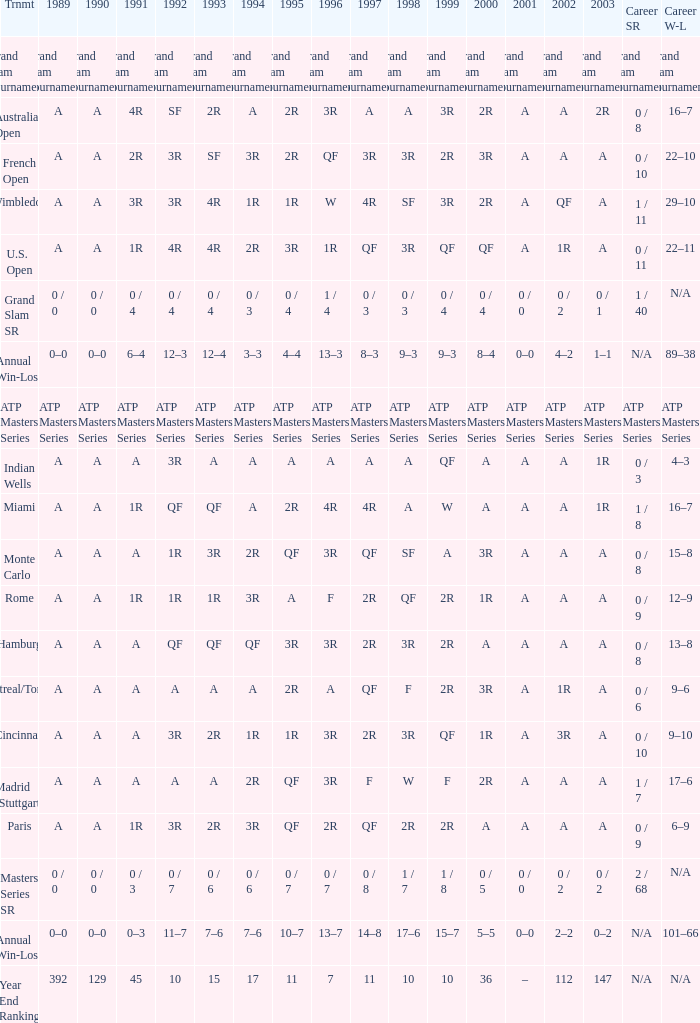Can you give me this table as a dict? {'header': ['Trnmt', '1989', '1990', '1991', '1992', '1993', '1994', '1995', '1996', '1997', '1998', '1999', '2000', '2001', '2002', '2003', 'Career SR', 'Career W-L'], 'rows': [['Grand Slam Tournaments', 'Grand Slam Tournaments', 'Grand Slam Tournaments', 'Grand Slam Tournaments', 'Grand Slam Tournaments', 'Grand Slam Tournaments', 'Grand Slam Tournaments', 'Grand Slam Tournaments', 'Grand Slam Tournaments', 'Grand Slam Tournaments', 'Grand Slam Tournaments', 'Grand Slam Tournaments', 'Grand Slam Tournaments', 'Grand Slam Tournaments', 'Grand Slam Tournaments', 'Grand Slam Tournaments', 'Grand Slam Tournaments', 'Grand Slam Tournaments'], ['Australian Open', 'A', 'A', '4R', 'SF', '2R', 'A', '2R', '3R', 'A', 'A', '3R', '2R', 'A', 'A', '2R', '0 / 8', '16–7'], ['French Open', 'A', 'A', '2R', '3R', 'SF', '3R', '2R', 'QF', '3R', '3R', '2R', '3R', 'A', 'A', 'A', '0 / 10', '22–10'], ['Wimbledon', 'A', 'A', '3R', '3R', '4R', '1R', '1R', 'W', '4R', 'SF', '3R', '2R', 'A', 'QF', 'A', '1 / 11', '29–10'], ['U.S. Open', 'A', 'A', '1R', '4R', '4R', '2R', '3R', '1R', 'QF', '3R', 'QF', 'QF', 'A', '1R', 'A', '0 / 11', '22–11'], ['Grand Slam SR', '0 / 0', '0 / 0', '0 / 4', '0 / 4', '0 / 4', '0 / 3', '0 / 4', '1 / 4', '0 / 3', '0 / 3', '0 / 4', '0 / 4', '0 / 0', '0 / 2', '0 / 1', '1 / 40', 'N/A'], ['Annual Win-Loss', '0–0', '0–0', '6–4', '12–3', '12–4', '3–3', '4–4', '13–3', '8–3', '9–3', '9–3', '8–4', '0–0', '4–2', '1–1', 'N/A', '89–38'], ['ATP Masters Series', 'ATP Masters Series', 'ATP Masters Series', 'ATP Masters Series', 'ATP Masters Series', 'ATP Masters Series', 'ATP Masters Series', 'ATP Masters Series', 'ATP Masters Series', 'ATP Masters Series', 'ATP Masters Series', 'ATP Masters Series', 'ATP Masters Series', 'ATP Masters Series', 'ATP Masters Series', 'ATP Masters Series', 'ATP Masters Series', 'ATP Masters Series'], ['Indian Wells', 'A', 'A', 'A', '3R', 'A', 'A', 'A', 'A', 'A', 'A', 'QF', 'A', 'A', 'A', '1R', '0 / 3', '4–3'], ['Miami', 'A', 'A', '1R', 'QF', 'QF', 'A', '2R', '4R', '4R', 'A', 'W', 'A', 'A', 'A', '1R', '1 / 8', '16–7'], ['Monte Carlo', 'A', 'A', 'A', '1R', '3R', '2R', 'QF', '3R', 'QF', 'SF', 'A', '3R', 'A', 'A', 'A', '0 / 8', '15–8'], ['Rome', 'A', 'A', '1R', '1R', '1R', '3R', 'A', 'F', '2R', 'QF', '2R', '1R', 'A', 'A', 'A', '0 / 9', '12–9'], ['Hamburg', 'A', 'A', 'A', 'QF', 'QF', 'QF', '3R', '3R', '2R', '3R', '2R', 'A', 'A', 'A', 'A', '0 / 8', '13–8'], ['Montreal/Toronto', 'A', 'A', 'A', 'A', 'A', 'A', '2R', 'A', 'QF', 'F', '2R', '3R', 'A', '1R', 'A', '0 / 6', '9–6'], ['Cincinnati', 'A', 'A', 'A', '3R', '2R', '1R', '1R', '3R', '2R', '3R', 'QF', '1R', 'A', '3R', 'A', '0 / 10', '9–10'], ['Madrid (Stuttgart)', 'A', 'A', 'A', 'A', 'A', '2R', 'QF', '3R', 'F', 'W', 'F', '2R', 'A', 'A', 'A', '1 / 7', '17–6'], ['Paris', 'A', 'A', '1R', '3R', '2R', '3R', 'QF', '2R', 'QF', '2R', '2R', 'A', 'A', 'A', 'A', '0 / 9', '6–9'], ['Masters Series SR', '0 / 0', '0 / 0', '0 / 3', '0 / 7', '0 / 6', '0 / 6', '0 / 7', '0 / 7', '0 / 8', '1 / 7', '1 / 8', '0 / 5', '0 / 0', '0 / 2', '0 / 2', '2 / 68', 'N/A'], ['Annual Win-Loss', '0–0', '0–0', '0–3', '11–7', '7–6', '7–6', '10–7', '13–7', '14–8', '17–6', '15–7', '5–5', '0–0', '2–2', '0–2', 'N/A', '101–66'], ['Year End Ranking', '392', '129', '45', '10', '15', '17', '11', '7', '11', '10', '10', '36', '–', '112', '147', 'N/A', 'N/A']]} What was the value in 1995 for A in 2000 at the Indian Wells tournament? A. 